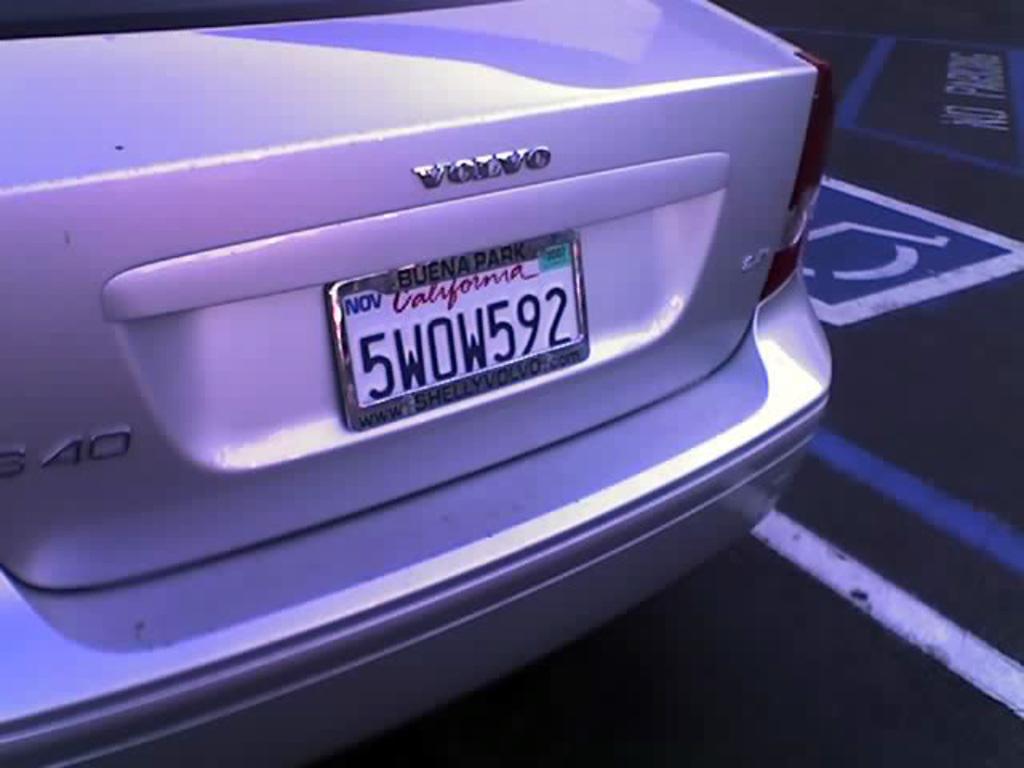Is buena park a city in california?
Give a very brief answer. Yes. This is car back side?
Offer a terse response. Yes. 